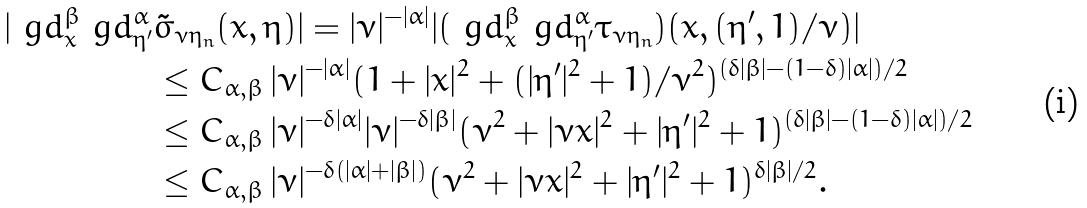Convert formula to latex. <formula><loc_0><loc_0><loc_500><loc_500>| \ g d ^ { \beta } _ { x } \ g d _ { \eta ^ { \prime } } ^ { \alpha } & \tilde { \sigma } _ { \nu \eta _ { n } } ( x , \eta ) | = | \nu | ^ { - | \alpha | } | ( \ g d ^ { \beta } _ { x } \ g d _ { \eta ^ { \prime } } ^ { \alpha } \tau _ { \nu \eta _ { n } } ) ( x , ( \eta ^ { \prime } , 1 ) / \nu ) | \\ & \leq C _ { \alpha , \beta } \, | \nu | ^ { - | \alpha | } ( 1 + | x | ^ { 2 } + ( | \eta ^ { \prime } | ^ { 2 } + 1 ) / \nu ^ { 2 } ) ^ { { ( \delta | \beta | - ( 1 - \delta ) | \alpha | ) } / 2 } \\ & \leq C _ { \alpha , \beta } \, | \nu | ^ { - \delta | \alpha | } | \nu | ^ { - \delta | \beta | } ( \nu ^ { 2 } + | \nu x | ^ { 2 } + | \eta ^ { \prime } | ^ { 2 } + 1 ) ^ { ( \delta | \beta | - ( 1 - \delta ) | \alpha | ) / 2 } \\ & \leq C _ { \alpha , \beta } \, | \nu | ^ { - \delta ( | \alpha | + | \beta | ) } ( \nu ^ { 2 } + | \nu x | ^ { 2 } + | \eta ^ { \prime } | ^ { 2 } + 1 ) ^ { \delta | \beta | / 2 } .</formula> 